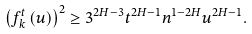<formula> <loc_0><loc_0><loc_500><loc_500>\left ( f _ { k } ^ { t } \left ( u \right ) \right ) ^ { 2 } \geq 3 ^ { 2 H - 3 } t ^ { 2 H - 1 } n ^ { 1 - 2 H } u ^ { 2 H - 1 } .</formula> 